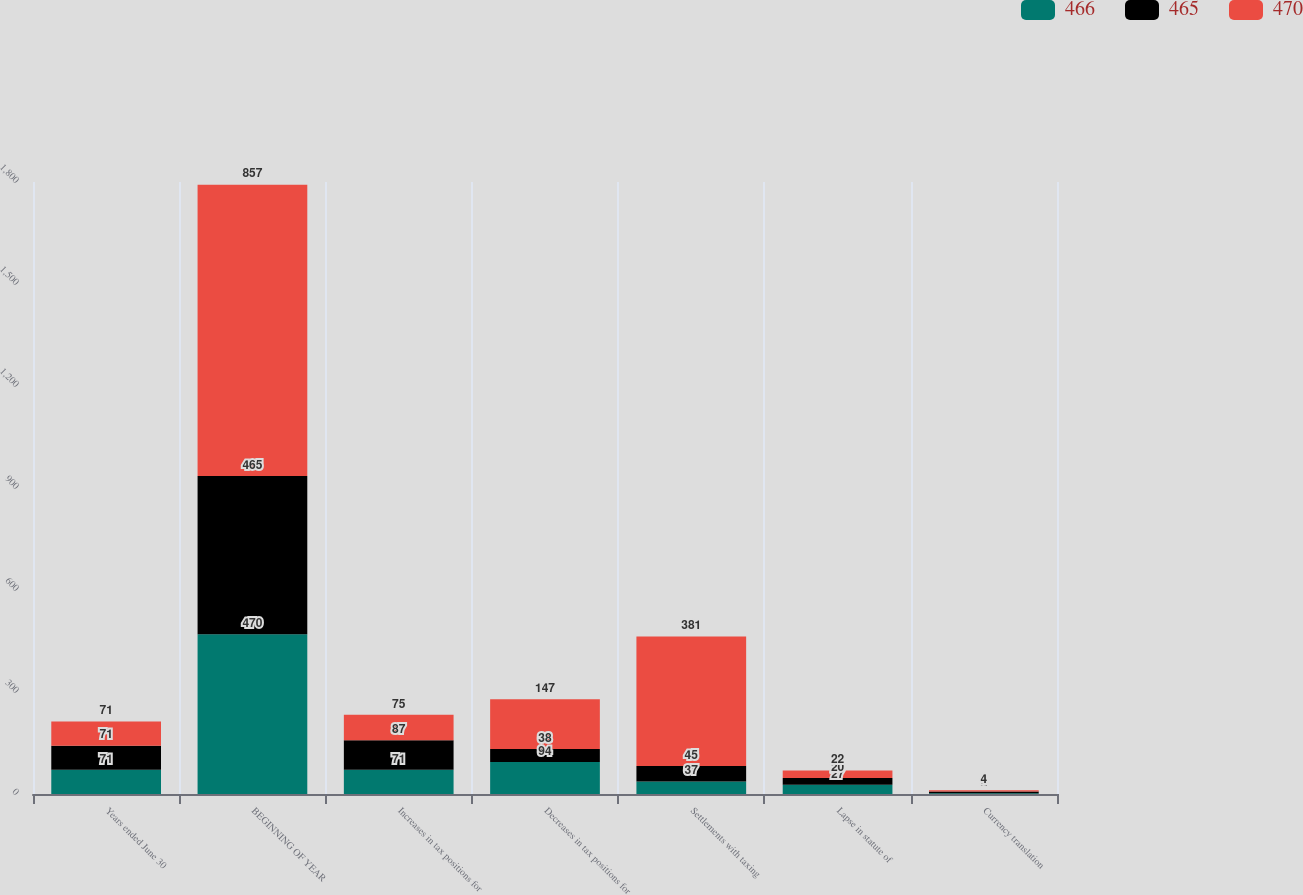Convert chart to OTSL. <chart><loc_0><loc_0><loc_500><loc_500><stacked_bar_chart><ecel><fcel>Years ended June 30<fcel>BEGINNING OF YEAR<fcel>Increases in tax positions for<fcel>Decreases in tax positions for<fcel>Settlements with taxing<fcel>Lapse in statute of<fcel>Currency translation<nl><fcel>466<fcel>71<fcel>470<fcel>71<fcel>94<fcel>37<fcel>27<fcel>2<nl><fcel>465<fcel>71<fcel>465<fcel>87<fcel>38<fcel>45<fcel>20<fcel>5<nl><fcel>470<fcel>71<fcel>857<fcel>75<fcel>147<fcel>381<fcel>22<fcel>4<nl></chart> 